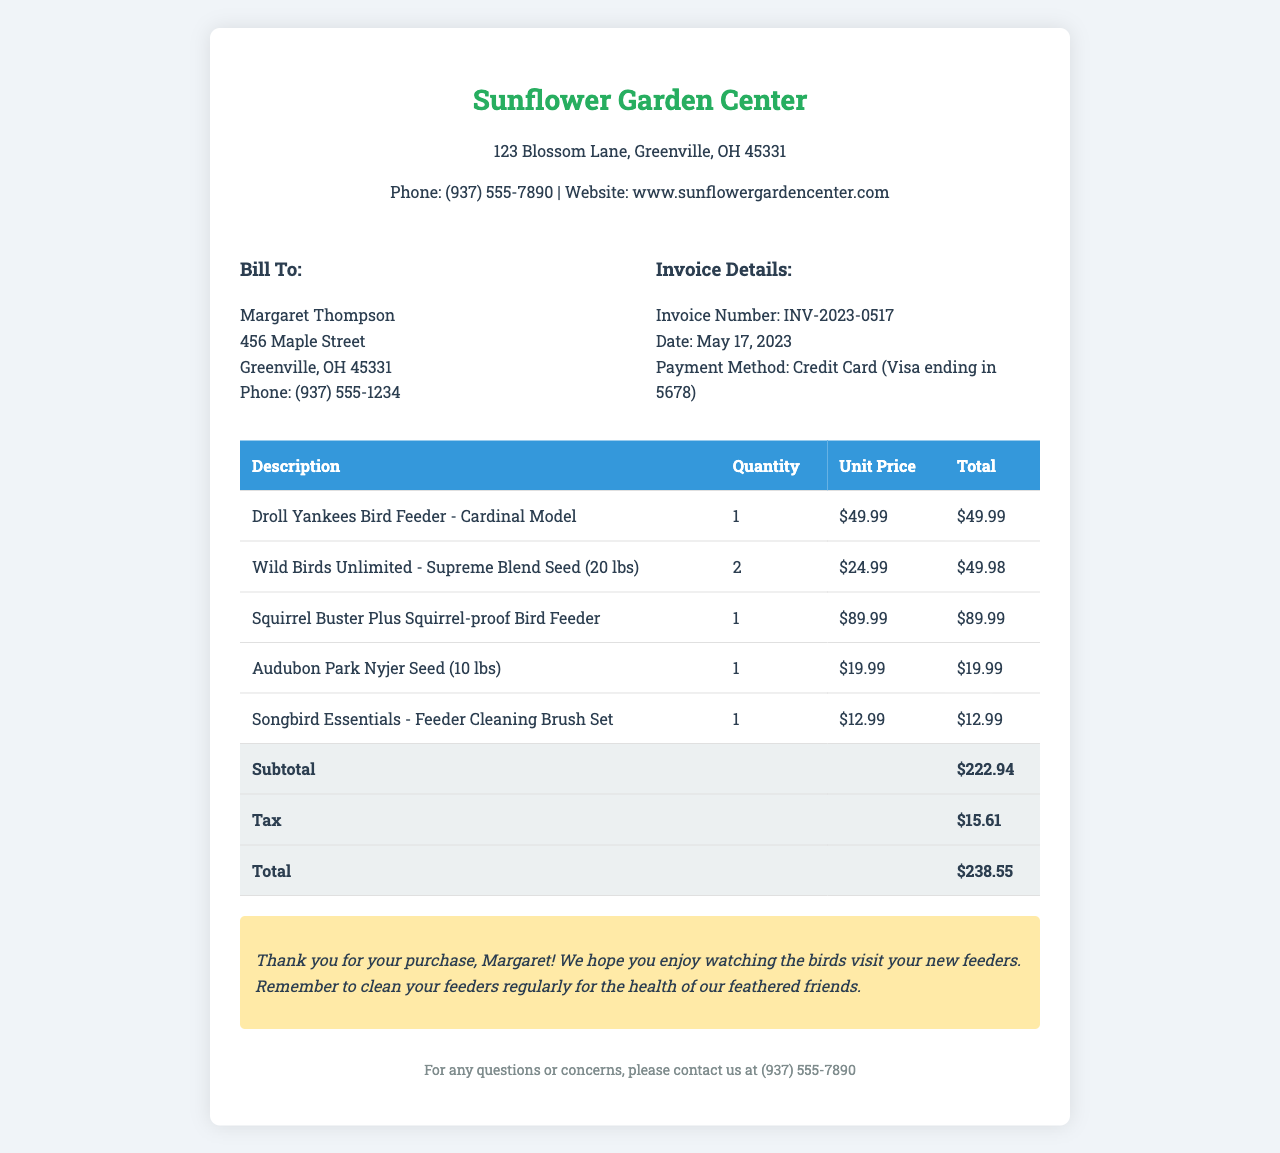What is the invoice number? The invoice number is stated in the invoice details section.
Answer: INV-2023-0517 What date was the invoice issued? The date is indicated alongside the invoice number.
Answer: May 17, 2023 Who is the bill recipient? The bill recipient's information is found in the "Bill To" section.
Answer: Margaret Thompson What is the total amount due? The total amount is at the bottom of the invoice in the total row.
Answer: $238.55 How many units of the Supreme Blend Seed were purchased? The quantity for this item can be seen in the itemized list of purchases.
Answer: 2 What is the subtotal amount? The subtotal is specified in the itemized section before taxes.
Answer: $222.94 What is the payment method used? The payment method is detailed in the invoice information section.
Answer: Credit Card (Visa ending in 5678) What type of bird feeder is the Squirrel Buster Plus? The description includes details about the product type.
Answer: Squirrel-proof What is the tax amount? The tax amount is listed in the total calculation section.
Answer: $15.61 